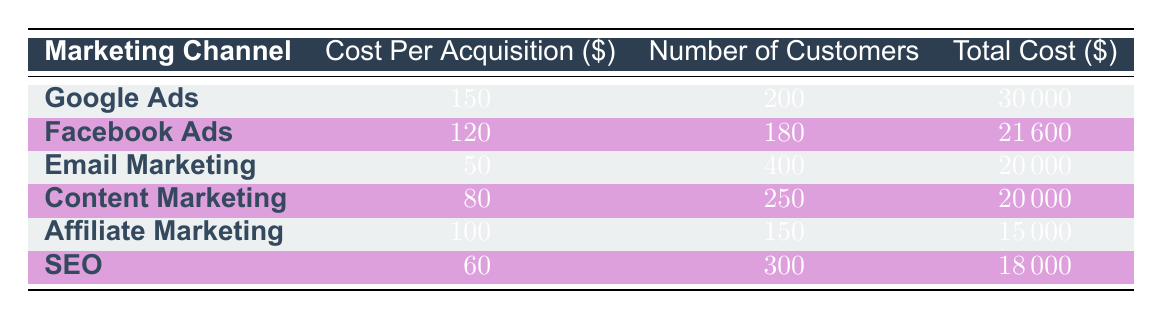What is the Customer Acquisition Cost for Email Marketing? The table directly shows the "Cost Per Acquisition" for "Email Marketing" as 50.
Answer: 50 Which marketing channel has the highest Total Cost? Looking at the "Total Cost" column, "Google Ads" has the highest total cost of 30000.
Answer: Google Ads How many customers were acquired through Facebook Ads? The "Number of Customers" for "Facebook Ads" is listed as 180.
Answer: 180 What is the average Cost Per Acquisition for all channels? Summing the "Cost Per Acquisition" values (150 + 120 + 50 + 80 + 100 + 60 = 560) and dividing by the number of channels (6) gives an average of 93.33.
Answer: 93.33 Is the Total Cost for Affiliate Marketing less than that for SEO? The "Total Cost" for "Affiliate Marketing" is 15000, while for "SEO" it is 18000. Since 15000 is less than 18000, the statement is true.
Answer: Yes Which marketing channel has the lowest Cost Per Acquisition? By reviewing the "Cost Per Acquisition" column, "Email Marketing" has the lowest value of 50.
Answer: Email Marketing What is the combined Total Cost of Content Marketing and Email Marketing? The Total Cost for "Content Marketing" is 20000 and for "Email Marketing" is 20000. Adding these gives 20000 + 20000 = 40000.
Answer: 40000 How many customers were acquired in total across all marketing channels? Adding the "Number of Customers" from each channel (200 + 180 + 400 + 250 + 150 + 300 = 1480) gives a total of 1480 customers acquired.
Answer: 1480 Is the Cost Per Acquisition for SEO higher than that for Affiliate Marketing? The "Cost Per Acquisition" is 60 for "SEO" and 100 for "Affiliate Marketing". Since 60 is not higher than 100, the answer is false.
Answer: No 